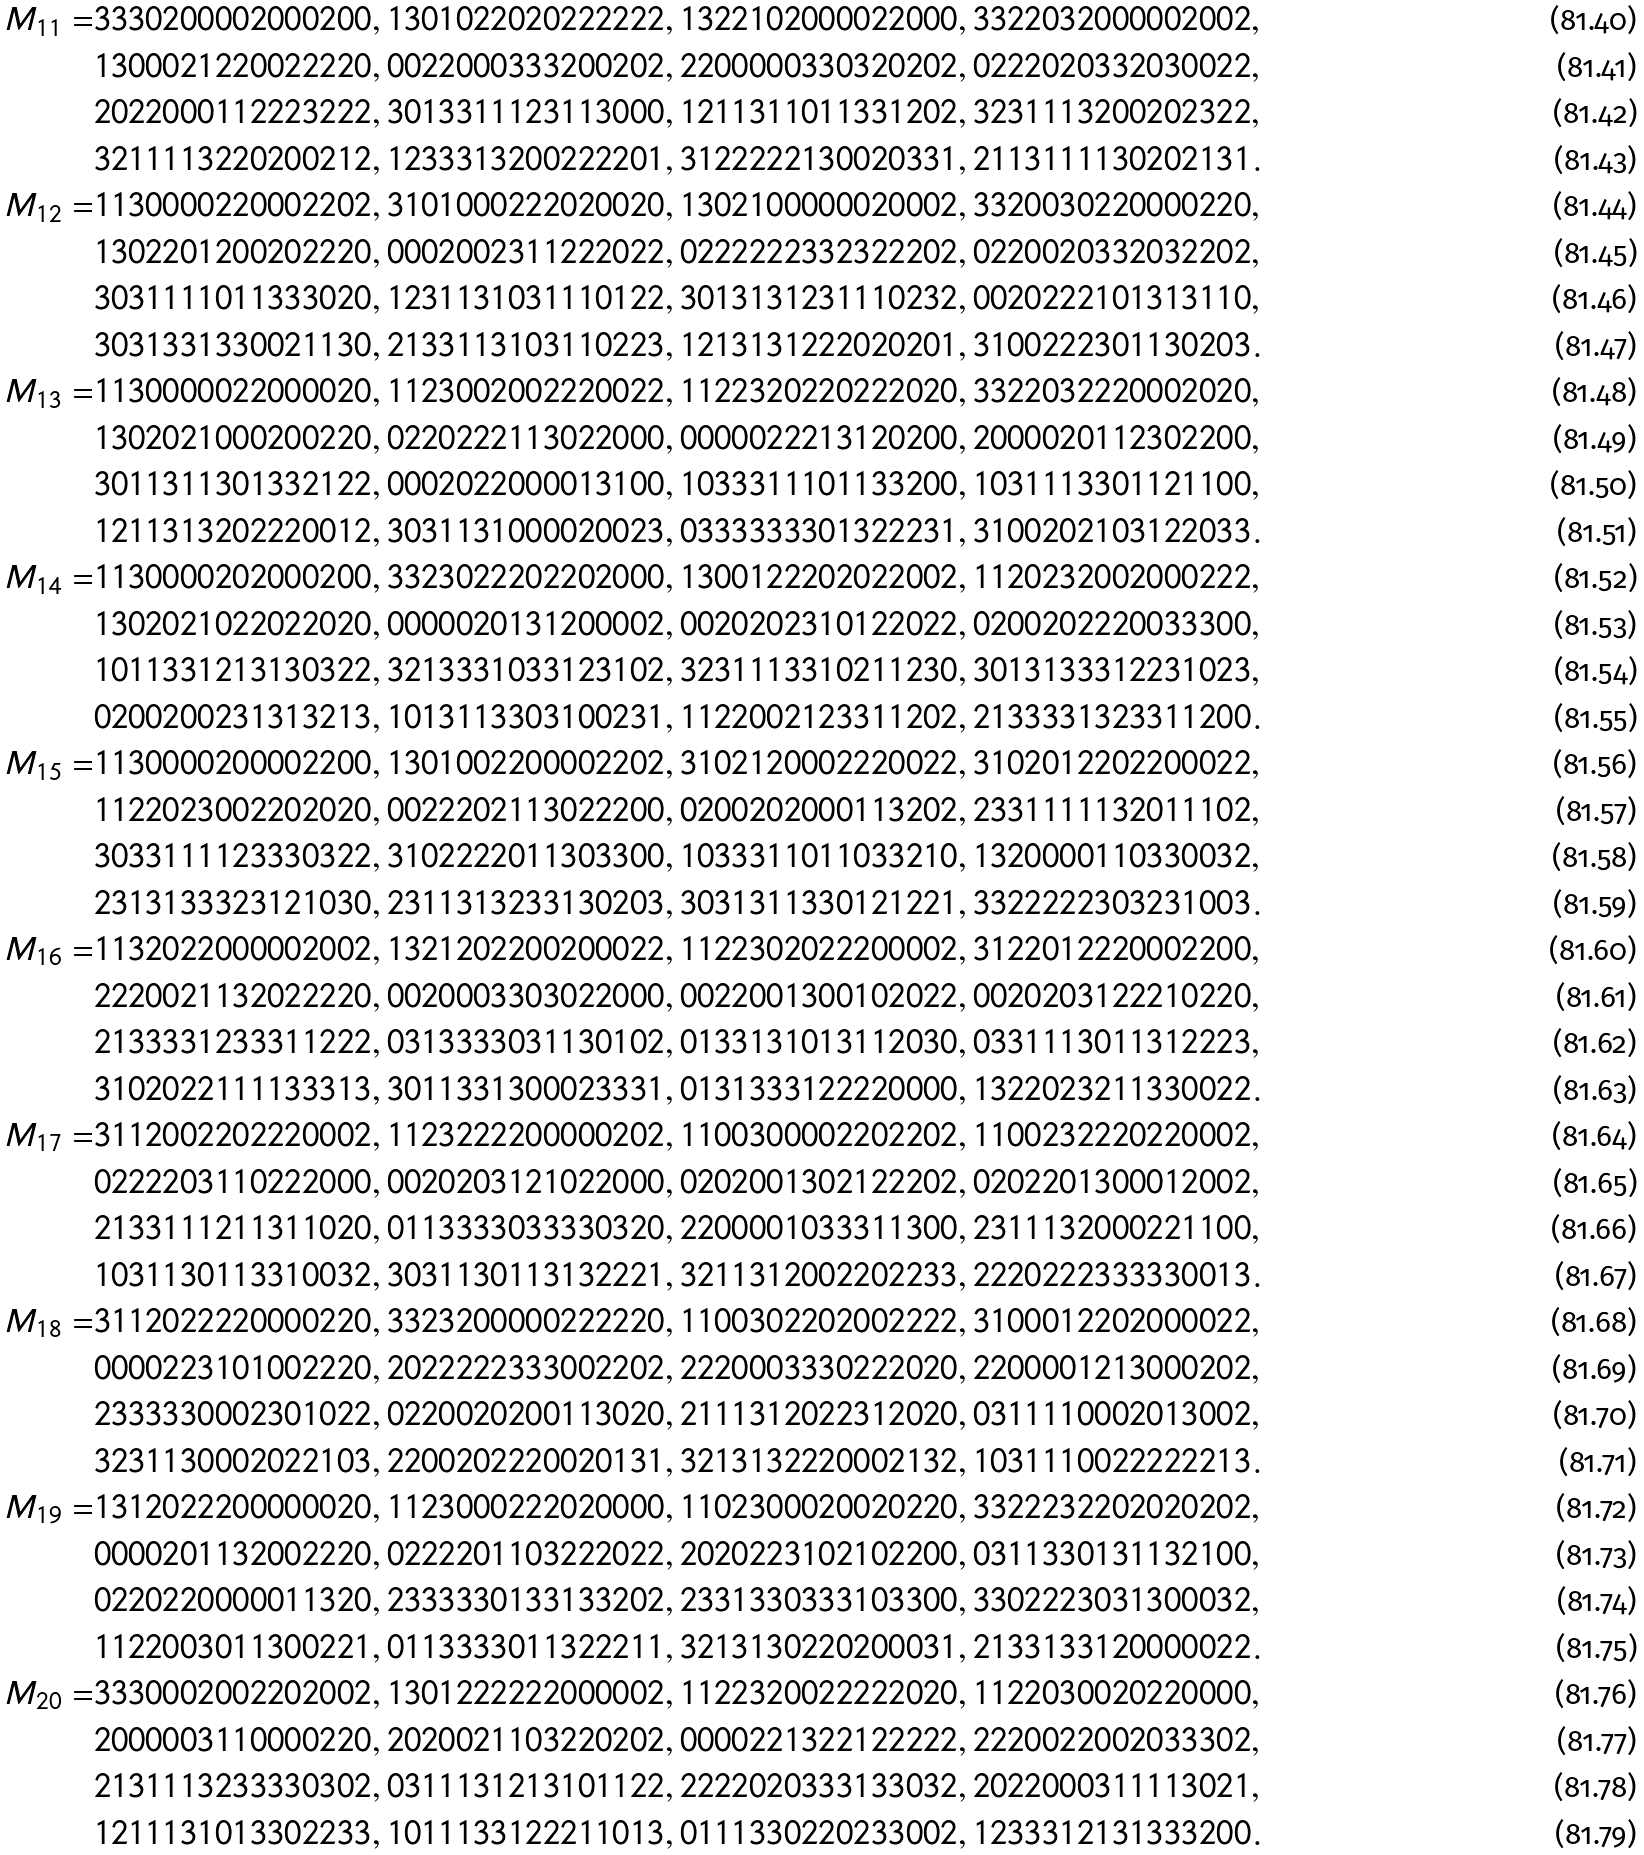<formula> <loc_0><loc_0><loc_500><loc_500>M _ { 1 1 } = & 3 3 3 0 2 0 0 0 0 2 0 0 0 2 0 0 , 1 3 0 1 0 2 2 0 2 0 2 2 2 2 2 2 , 1 3 2 2 1 0 2 0 0 0 0 2 2 0 0 0 , 3 3 2 2 0 3 2 0 0 0 0 0 2 0 0 2 , \\ & 1 3 0 0 0 2 1 2 2 0 0 2 2 2 2 0 , 0 0 2 2 0 0 0 3 3 3 2 0 0 2 0 2 , 2 2 0 0 0 0 0 3 3 0 3 2 0 2 0 2 , 0 2 2 2 0 2 0 3 3 2 0 3 0 0 2 2 , \\ & 2 0 2 2 0 0 0 1 1 2 2 2 3 2 2 2 , 3 0 1 3 3 1 1 1 2 3 1 1 3 0 0 0 , 1 2 1 1 3 1 1 0 1 1 3 3 1 2 0 2 , 3 2 3 1 1 1 3 2 0 0 2 0 2 3 2 2 , \\ & 3 2 1 1 1 1 3 2 2 0 2 0 0 2 1 2 , 1 2 3 3 3 1 3 2 0 0 2 2 2 2 0 1 , 3 1 2 2 2 2 2 1 3 0 0 2 0 3 3 1 , 2 1 1 3 1 1 1 1 3 0 2 0 2 1 3 1 . \\ M _ { 1 2 } = & 1 1 3 0 0 0 0 2 2 0 0 0 2 2 0 2 , 3 1 0 1 0 0 0 2 2 2 0 2 0 0 2 0 , 1 3 0 2 1 0 0 0 0 0 0 2 0 0 0 2 , 3 3 2 0 0 3 0 2 2 0 0 0 0 2 2 0 , \\ & 1 3 0 2 2 0 1 2 0 0 2 0 2 2 2 0 , 0 0 0 2 0 0 2 3 1 1 2 2 2 0 2 2 , 0 2 2 2 2 2 2 3 3 2 3 2 2 2 0 2 , 0 2 2 0 0 2 0 3 3 2 0 3 2 2 0 2 , \\ & 3 0 3 1 1 1 1 0 1 1 3 3 3 0 2 0 , 1 2 3 1 1 3 1 0 3 1 1 1 0 1 2 2 , 3 0 1 3 1 3 1 2 3 1 1 1 0 2 3 2 , 0 0 2 0 2 2 2 1 0 1 3 1 3 1 1 0 , \\ & 3 0 3 1 3 3 1 3 3 0 0 2 1 1 3 0 , 2 1 3 3 1 1 3 1 0 3 1 1 0 2 2 3 , 1 2 1 3 1 3 1 2 2 2 0 2 0 2 0 1 , 3 1 0 0 2 2 2 3 0 1 1 3 0 2 0 3 . \\ M _ { 1 3 } = & 1 1 3 0 0 0 0 0 2 2 0 0 0 0 2 0 , 1 1 2 3 0 0 2 0 0 2 2 2 0 0 2 2 , 1 1 2 2 3 2 0 2 2 0 2 2 2 0 2 0 , 3 3 2 2 0 3 2 2 2 0 0 0 2 0 2 0 , \\ & 1 3 0 2 0 2 1 0 0 0 2 0 0 2 2 0 , 0 2 2 0 2 2 2 1 1 3 0 2 2 0 0 0 , 0 0 0 0 0 2 2 2 1 3 1 2 0 2 0 0 , 2 0 0 0 0 2 0 1 1 2 3 0 2 2 0 0 , \\ & 3 0 1 1 3 1 1 3 0 1 3 3 2 1 2 2 , 0 0 0 2 0 2 2 0 0 0 0 1 3 1 0 0 , 1 0 3 3 3 1 1 1 0 1 1 3 3 2 0 0 , 1 0 3 1 1 1 3 3 0 1 1 2 1 1 0 0 , \\ & 1 2 1 1 3 1 3 2 0 2 2 2 0 0 1 2 , 3 0 3 1 1 3 1 0 0 0 0 2 0 0 2 3 , 0 3 3 3 3 3 3 3 0 1 3 2 2 2 3 1 , 3 1 0 0 2 0 2 1 0 3 1 2 2 0 3 3 . \\ M _ { 1 4 } = & 1 1 3 0 0 0 0 2 0 2 0 0 0 2 0 0 , 3 3 2 3 0 2 2 2 0 2 2 0 2 0 0 0 , 1 3 0 0 1 2 2 2 0 2 0 2 2 0 0 2 , 1 1 2 0 2 3 2 0 0 2 0 0 0 2 2 2 , \\ & 1 3 0 2 0 2 1 0 2 2 0 2 2 0 2 0 , 0 0 0 0 0 2 0 1 3 1 2 0 0 0 0 2 , 0 0 2 0 2 0 2 3 1 0 1 2 2 0 2 2 , 0 2 0 0 2 0 2 2 2 0 0 3 3 3 0 0 , \\ & 1 0 1 1 3 3 1 2 1 3 1 3 0 3 2 2 , 3 2 1 3 3 3 1 0 3 3 1 2 3 1 0 2 , 3 2 3 1 1 1 3 3 1 0 2 1 1 2 3 0 , 3 0 1 3 1 3 3 3 1 2 2 3 1 0 2 3 , \\ & 0 2 0 0 2 0 0 2 3 1 3 1 3 2 1 3 , 1 0 1 3 1 1 3 3 0 3 1 0 0 2 3 1 , 1 1 2 2 0 0 2 1 2 3 3 1 1 2 0 2 , 2 1 3 3 3 3 1 3 2 3 3 1 1 2 0 0 . \\ M _ { 1 5 } = & 1 1 3 0 0 0 0 2 0 0 0 0 2 2 0 0 , 1 3 0 1 0 0 2 2 0 0 0 0 2 2 0 2 , 3 1 0 2 1 2 0 0 0 2 2 2 0 0 2 2 , 3 1 0 2 0 1 2 2 0 2 2 0 0 0 2 2 , \\ & 1 1 2 2 0 2 3 0 0 2 2 0 2 0 2 0 , 0 0 2 2 2 0 2 1 1 3 0 2 2 2 0 0 , 0 2 0 0 2 0 2 0 0 0 1 1 3 2 0 2 , 2 3 3 1 1 1 1 1 3 2 0 1 1 1 0 2 , \\ & 3 0 3 3 1 1 1 1 2 3 3 3 0 3 2 2 , 3 1 0 2 2 2 2 0 1 1 3 0 3 3 0 0 , 1 0 3 3 3 1 1 0 1 1 0 3 3 2 1 0 , 1 3 2 0 0 0 0 1 1 0 3 3 0 0 3 2 , \\ & 2 3 1 3 1 3 3 3 2 3 1 2 1 0 3 0 , 2 3 1 1 3 1 3 2 3 3 1 3 0 2 0 3 , 3 0 3 1 3 1 1 3 3 0 1 2 1 2 2 1 , 3 3 2 2 2 2 2 3 0 3 2 3 1 0 0 3 . \\ M _ { 1 6 } = & 1 1 3 2 0 2 2 0 0 0 0 0 2 0 0 2 , 1 3 2 1 2 0 2 2 0 0 2 0 0 0 2 2 , 1 1 2 2 3 0 2 0 2 2 2 0 0 0 0 2 , 3 1 2 2 0 1 2 2 2 0 0 0 2 2 0 0 , \\ & 2 2 2 0 0 2 1 1 3 2 0 2 2 2 2 0 , 0 0 2 0 0 0 3 3 0 3 0 2 2 0 0 0 , 0 0 2 2 0 0 1 3 0 0 1 0 2 0 2 2 , 0 0 2 0 2 0 3 1 2 2 2 1 0 2 2 0 , \\ & 2 1 3 3 3 3 1 2 3 3 3 1 1 2 2 2 , 0 3 1 3 3 3 3 0 3 1 1 3 0 1 0 2 , 0 1 3 3 1 3 1 0 1 3 1 1 2 0 3 0 , 0 3 3 1 1 1 3 0 1 1 3 1 2 2 2 3 , \\ & 3 1 0 2 0 2 2 1 1 1 1 3 3 3 1 3 , 3 0 1 1 3 3 1 3 0 0 0 2 3 3 3 1 , 0 1 3 1 3 3 3 1 2 2 2 2 0 0 0 0 , 1 3 2 2 0 2 3 2 1 1 3 3 0 0 2 2 . \\ M _ { 1 7 } = & 3 1 1 2 0 0 2 2 0 2 2 2 0 0 0 2 , 1 1 2 3 2 2 2 2 0 0 0 0 0 2 0 2 , 1 1 0 0 3 0 0 0 0 2 2 0 2 2 0 2 , 1 1 0 0 2 3 2 2 2 0 2 2 0 0 0 2 , \\ & 0 2 2 2 2 0 3 1 1 0 2 2 2 0 0 0 , 0 0 2 0 2 0 3 1 2 1 0 2 2 0 0 0 , 0 2 0 2 0 0 1 3 0 2 1 2 2 2 0 2 , 0 2 0 2 2 0 1 3 0 0 0 1 2 0 0 2 , \\ & 2 1 3 3 1 1 1 2 1 1 3 1 1 0 2 0 , 0 1 1 3 3 3 3 0 3 3 3 3 0 3 2 0 , 2 2 0 0 0 0 1 0 3 3 3 1 1 3 0 0 , 2 3 1 1 1 3 2 0 0 0 2 2 1 1 0 0 , \\ & 1 0 3 1 1 3 0 1 1 3 3 1 0 0 3 2 , 3 0 3 1 1 3 0 1 1 3 1 3 2 2 2 1 , 3 2 1 1 3 1 2 0 0 2 2 0 2 2 3 3 , 2 2 2 0 2 2 2 3 3 3 3 3 0 0 1 3 . \\ M _ { 1 8 } = & 3 1 1 2 0 2 2 2 2 0 0 0 0 2 2 0 , 3 3 2 3 2 0 0 0 0 0 2 2 2 2 2 0 , 1 1 0 0 3 0 2 2 0 2 0 0 2 2 2 2 , 3 1 0 0 0 1 2 2 0 2 0 0 0 0 2 2 , \\ & 0 0 0 0 2 2 3 1 0 1 0 0 2 2 2 0 , 2 0 2 2 2 2 2 3 3 3 0 0 2 2 0 2 , 2 2 2 0 0 0 3 3 3 0 2 2 2 0 2 0 , 2 2 0 0 0 0 1 2 1 3 0 0 0 2 0 2 , \\ & 2 3 3 3 3 3 0 0 0 2 3 0 1 0 2 2 , 0 2 2 0 0 2 0 2 0 0 1 1 3 0 2 0 , 2 1 1 1 3 1 2 0 2 2 3 1 2 0 2 0 , 0 3 1 1 1 1 0 0 0 2 0 1 3 0 0 2 , \\ & 3 2 3 1 1 3 0 0 0 2 0 2 2 1 0 3 , 2 2 0 0 2 0 2 2 2 0 0 2 0 1 3 1 , 3 2 1 3 1 3 2 2 2 0 0 0 2 1 3 2 , 1 0 3 1 1 1 0 0 2 2 2 2 2 2 1 3 . \\ M _ { 1 9 } = & 1 3 1 2 0 2 2 2 0 0 0 0 0 0 2 0 , 1 1 2 3 0 0 0 2 2 2 0 2 0 0 0 0 , 1 1 0 2 3 0 0 0 2 0 0 2 0 2 2 0 , 3 3 2 2 2 3 2 2 0 2 0 2 0 2 0 2 , \\ & 0 0 0 0 2 0 1 1 3 2 0 0 2 2 2 0 , 0 2 2 2 2 0 1 1 0 3 2 2 2 0 2 2 , 2 0 2 0 2 2 3 1 0 2 1 0 2 2 0 0 , 0 3 1 1 3 3 0 1 3 1 1 3 2 1 0 0 , \\ & 0 2 2 0 2 2 0 0 0 0 0 1 1 3 2 0 , 2 3 3 3 3 3 0 1 3 3 1 3 3 2 0 2 , 2 3 3 1 3 3 0 3 3 3 1 0 3 3 0 0 , 3 3 0 2 2 2 3 0 3 1 3 0 0 0 3 2 , \\ & 1 1 2 2 0 0 3 0 1 1 3 0 0 2 2 1 , 0 1 1 3 3 3 3 0 1 1 3 2 2 2 1 1 , 3 2 1 3 1 3 0 2 2 0 2 0 0 0 3 1 , 2 1 3 3 1 3 3 1 2 0 0 0 0 0 2 2 . \\ M _ { 2 0 } = & 3 3 3 0 0 0 2 0 0 2 2 0 2 0 0 2 , 1 3 0 1 2 2 2 2 2 2 0 0 0 0 0 2 , 1 1 2 2 3 2 0 0 2 2 2 2 2 0 2 0 , 1 1 2 2 0 3 0 0 2 0 2 2 0 0 0 0 , \\ & 2 0 0 0 0 0 3 1 1 0 0 0 0 2 2 0 , 2 0 2 0 0 2 1 1 0 3 2 2 0 2 0 2 , 0 0 0 0 2 2 1 3 2 2 1 2 2 2 2 2 , 2 2 2 0 0 2 2 0 0 2 0 3 3 3 0 2 , \\ & 2 1 3 1 1 1 3 2 3 3 3 3 0 3 0 2 , 0 3 1 1 1 3 1 2 1 3 1 0 1 1 2 2 , 2 2 2 2 0 2 0 3 3 3 1 3 3 0 3 2 , 2 0 2 2 0 0 0 3 1 1 1 1 3 0 2 1 , \\ & 1 2 1 1 1 3 1 0 1 3 3 0 2 2 3 3 , 1 0 1 1 1 3 3 1 2 2 2 1 1 0 1 3 , 0 1 1 1 3 3 0 2 2 0 2 3 3 0 0 2 , 1 2 3 3 3 1 2 1 3 1 3 3 3 2 0 0 .</formula> 